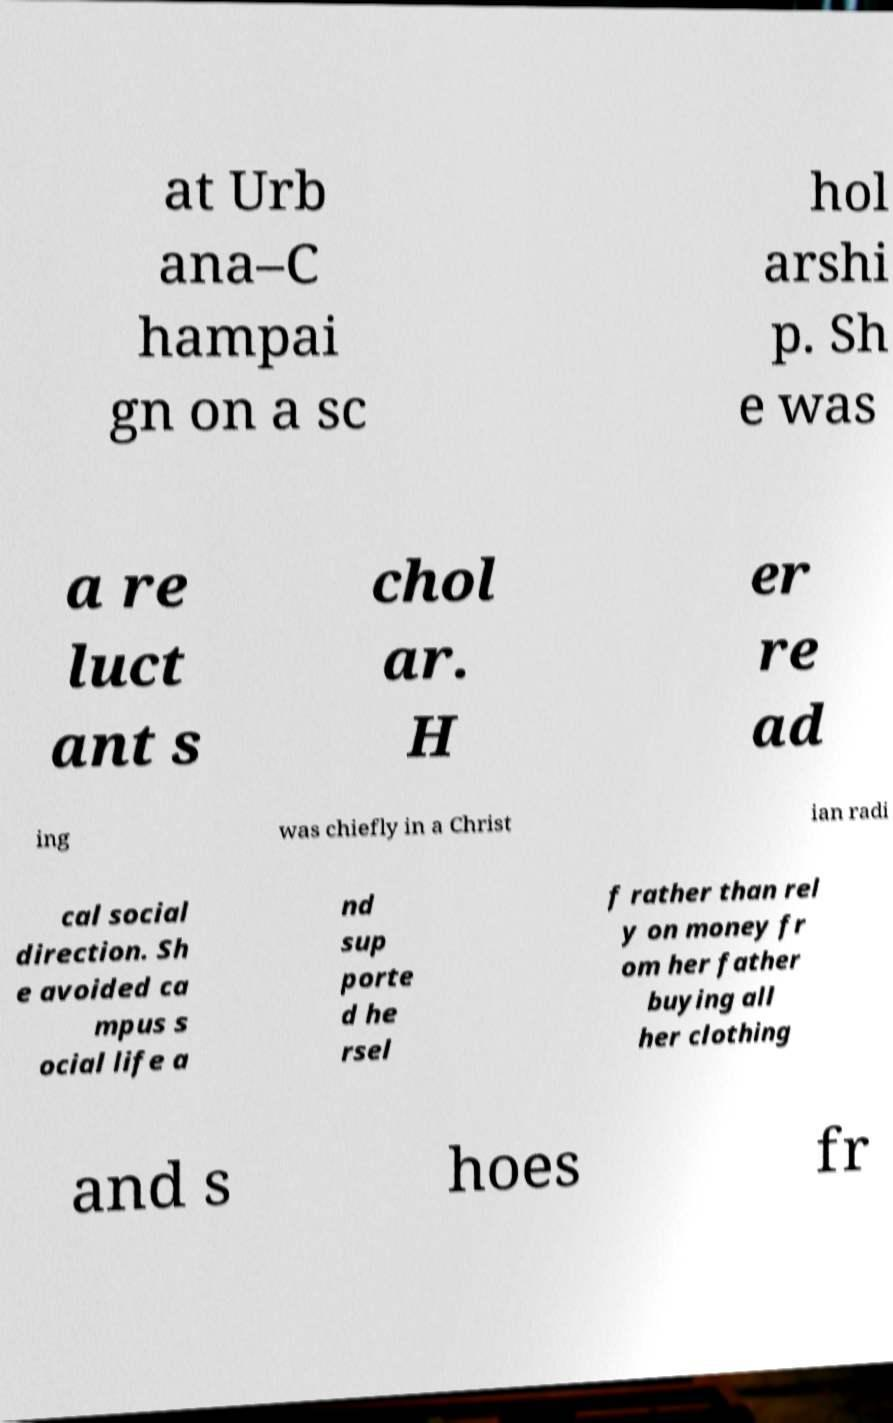What messages or text are displayed in this image? I need them in a readable, typed format. at Urb ana–C hampai gn on a sc hol arshi p. Sh e was a re luct ant s chol ar. H er re ad ing was chiefly in a Christ ian radi cal social direction. Sh e avoided ca mpus s ocial life a nd sup porte d he rsel f rather than rel y on money fr om her father buying all her clothing and s hoes fr 